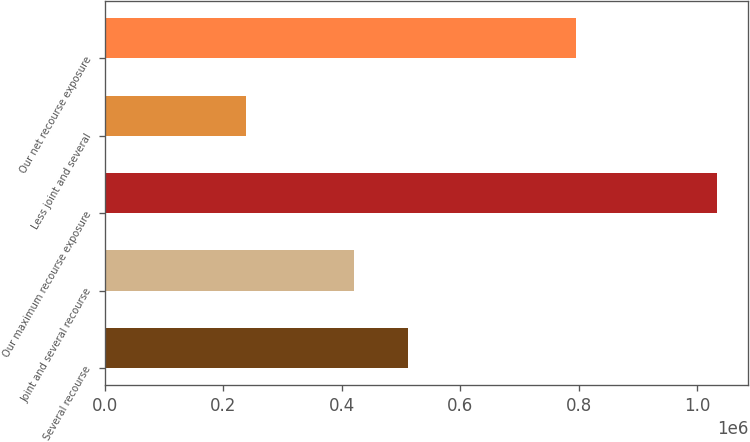Convert chart to OTSL. <chart><loc_0><loc_0><loc_500><loc_500><bar_chart><fcel>Several recourse<fcel>Joint and several recourse<fcel>Our maximum recourse exposure<fcel>Less joint and several<fcel>Our net recourse exposure<nl><fcel>511873<fcel>420813<fcel>1.03363e+06<fcel>238692<fcel>794934<nl></chart> 